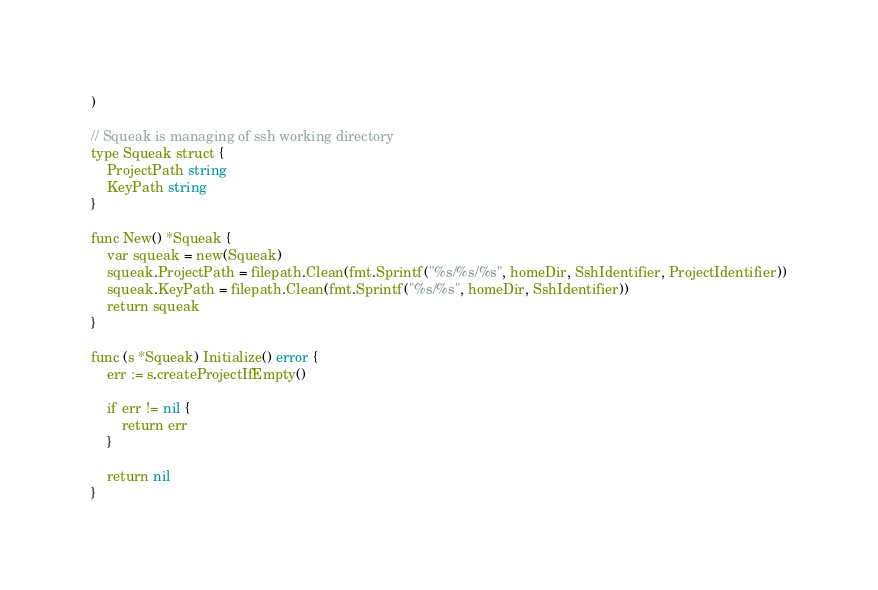Convert code to text. <code><loc_0><loc_0><loc_500><loc_500><_Go_>)

// Squeak is managing of ssh working directory
type Squeak struct {
	ProjectPath string
	KeyPath string
}

func New() *Squeak {
	var squeak = new(Squeak)
	squeak.ProjectPath = filepath.Clean(fmt.Sprintf("%s/%s/%s", homeDir, SshIdentifier, ProjectIdentifier))
	squeak.KeyPath = filepath.Clean(fmt.Sprintf("%s/%s", homeDir, SshIdentifier))
	return squeak
}

func (s *Squeak) Initialize() error {
	err := s.createProjectIfEmpty()

	if err != nil {
		return err
	}

	return nil
}

</code> 